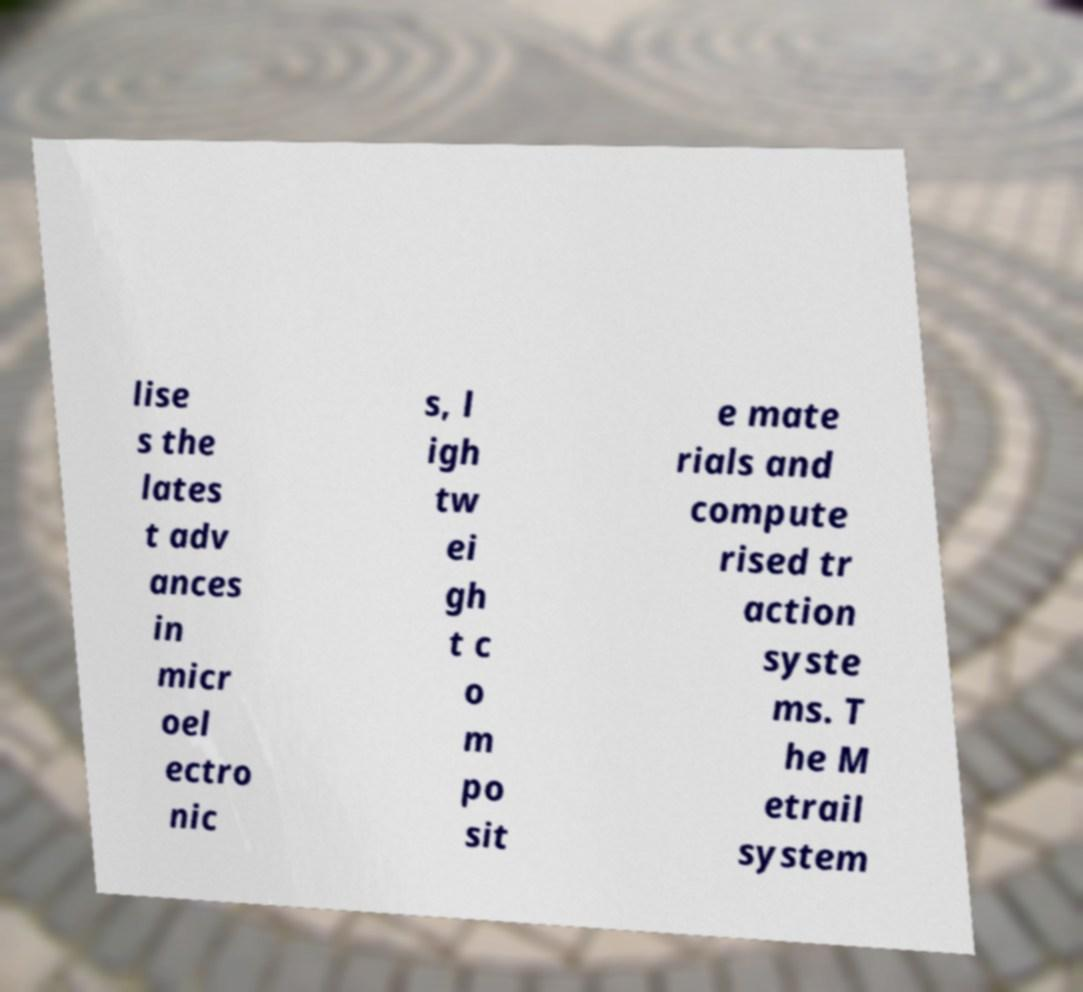There's text embedded in this image that I need extracted. Can you transcribe it verbatim? lise s the lates t adv ances in micr oel ectro nic s, l igh tw ei gh t c o m po sit e mate rials and compute rised tr action syste ms. T he M etrail system 